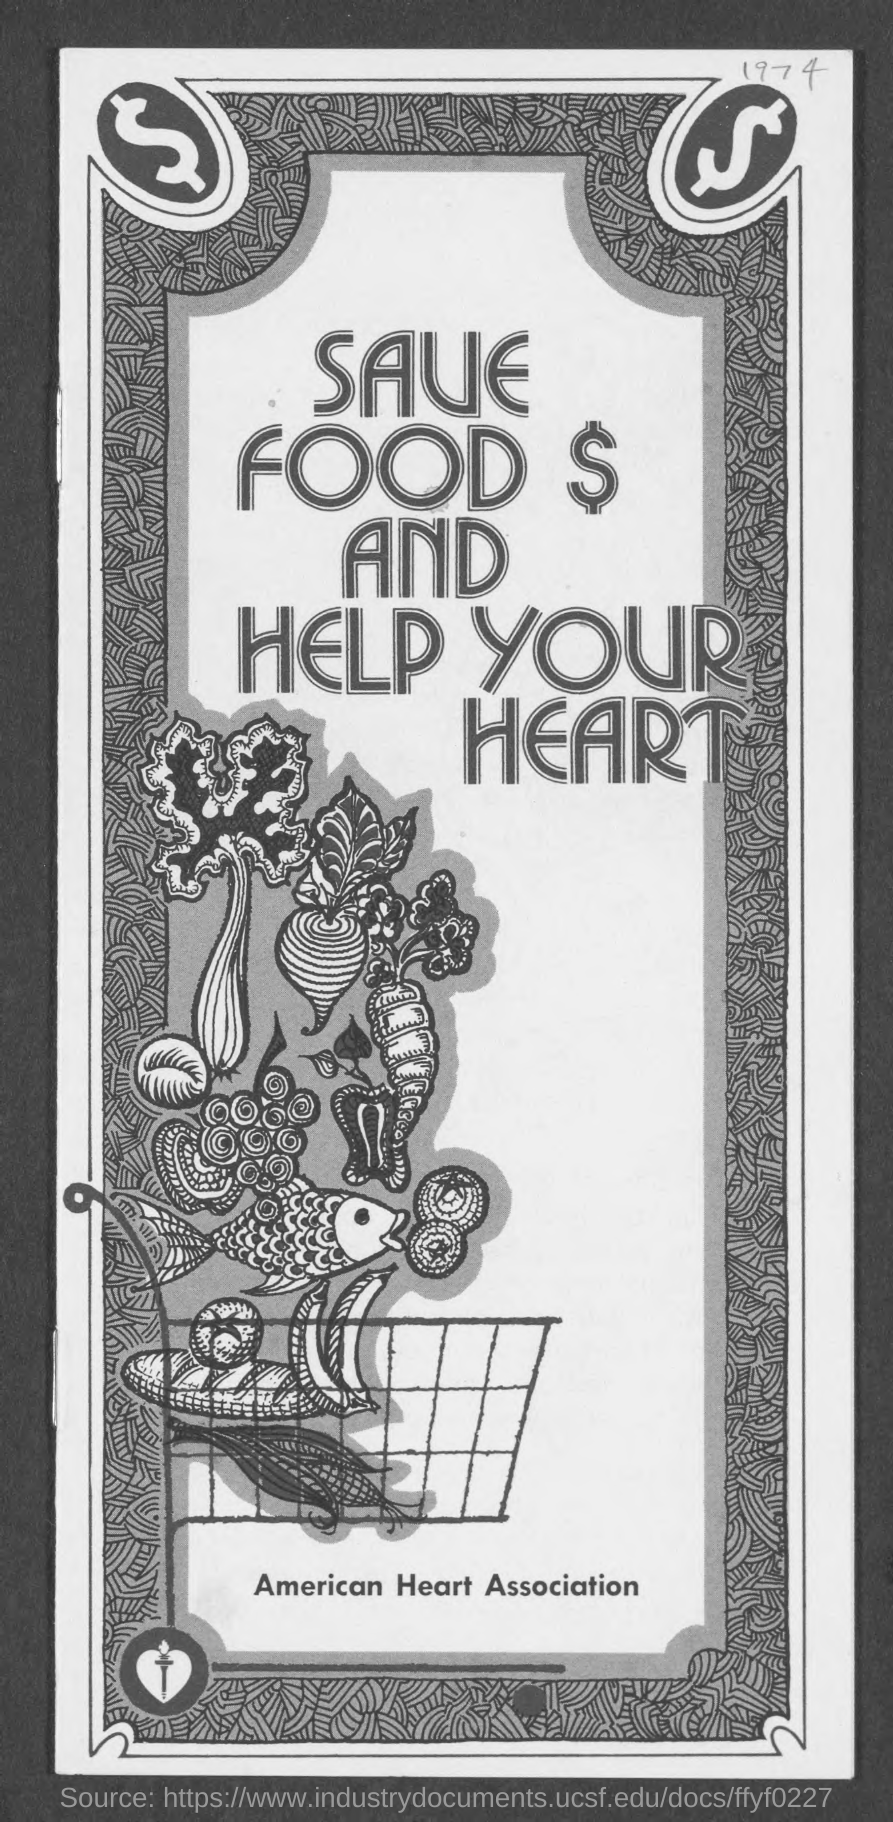Point out several critical features in this image. The American Heart Association is mentioned in this document. The year is 1974. 